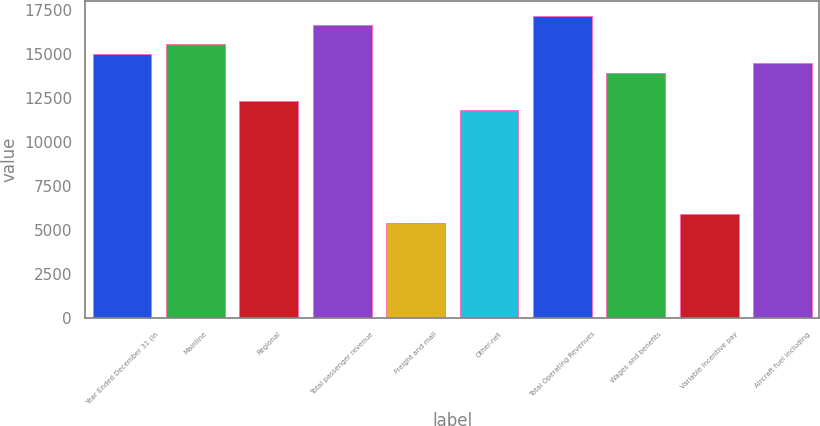Convert chart to OTSL. <chart><loc_0><loc_0><loc_500><loc_500><bar_chart><fcel>Year Ended December 31 (in<fcel>Mainline<fcel>Regional<fcel>Total passenger revenue<fcel>Freight and mail<fcel>Other-net<fcel>Total Operating Revenues<fcel>Wages and benefits<fcel>Variable incentive pay<fcel>Aircraft fuel including<nl><fcel>15029.5<fcel>15566.2<fcel>12345.8<fcel>16639.8<fcel>5368<fcel>11809<fcel>17176.5<fcel>13956<fcel>5904.75<fcel>14492.8<nl></chart> 